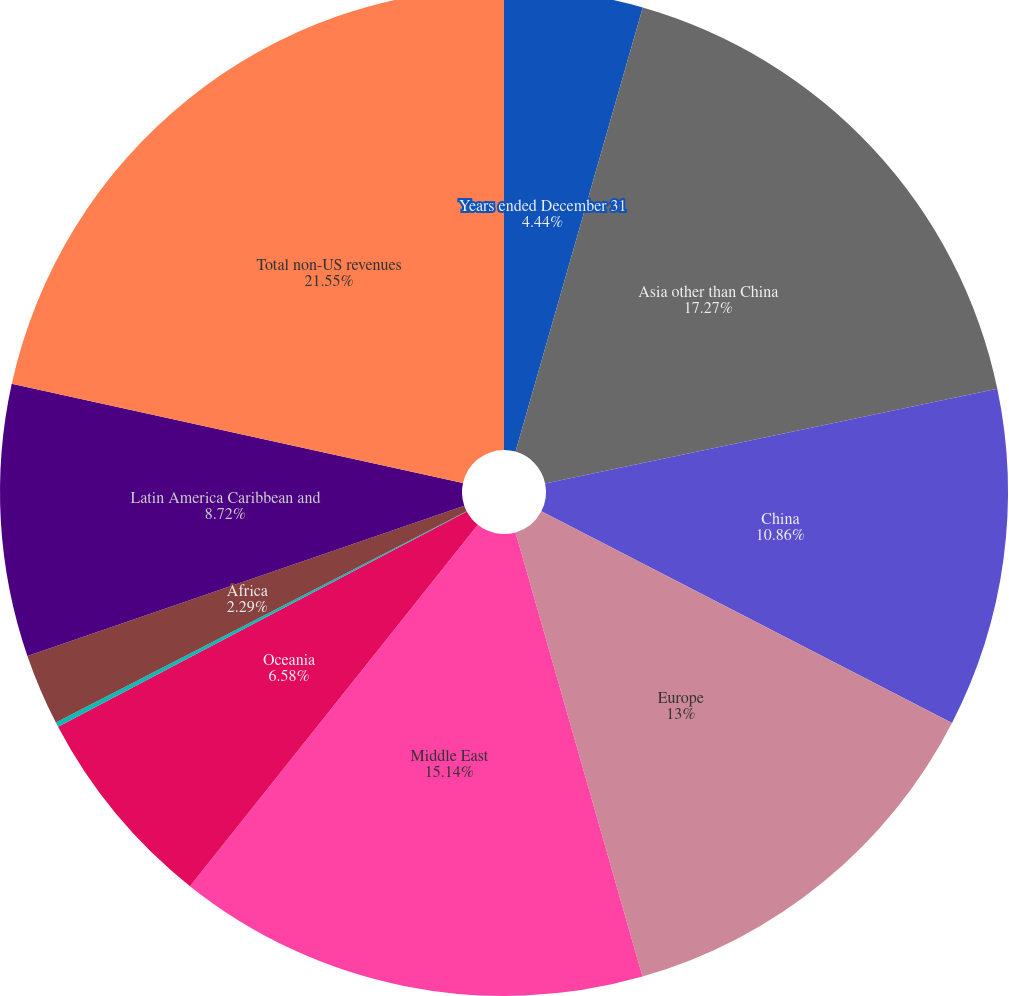Convert chart to OTSL. <chart><loc_0><loc_0><loc_500><loc_500><pie_chart><fcel>Years ended December 31<fcel>Asia other than China<fcel>China<fcel>Europe<fcel>Middle East<fcel>Oceania<fcel>Canada<fcel>Africa<fcel>Latin America Caribbean and<fcel>Total non-US revenues<nl><fcel>4.44%<fcel>17.28%<fcel>10.86%<fcel>13.0%<fcel>15.14%<fcel>6.58%<fcel>0.15%<fcel>2.29%<fcel>8.72%<fcel>21.56%<nl></chart> 